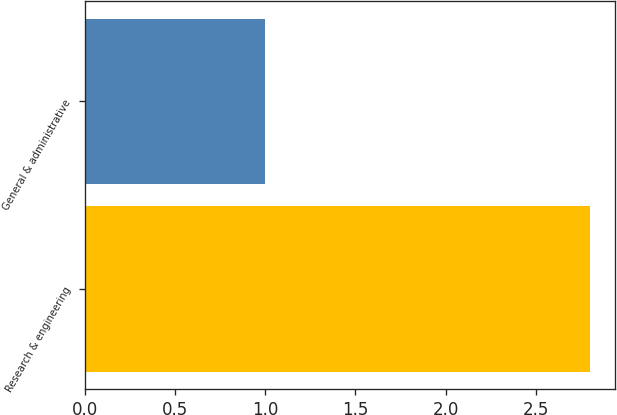Convert chart. <chart><loc_0><loc_0><loc_500><loc_500><bar_chart><fcel>Research & engineering<fcel>General & administrative<nl><fcel>2.8<fcel>1<nl></chart> 